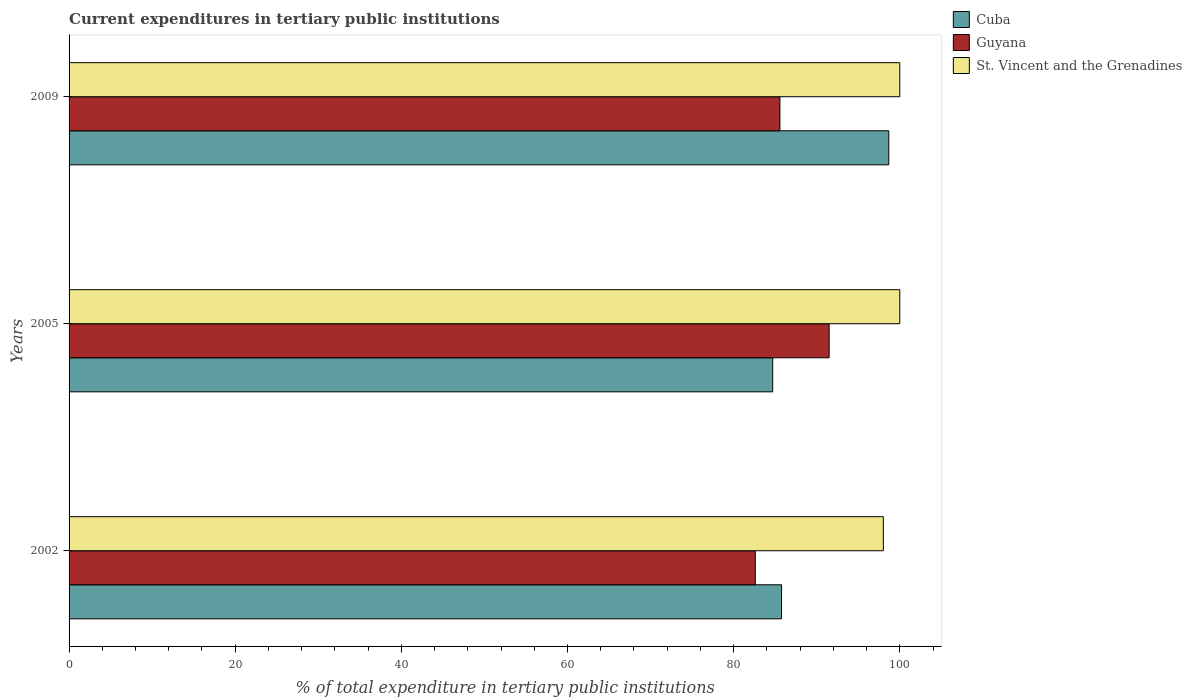Are the number of bars on each tick of the Y-axis equal?
Keep it short and to the point. Yes. How many bars are there on the 1st tick from the top?
Your answer should be very brief. 3. What is the current expenditures in tertiary public institutions in Guyana in 2002?
Ensure brevity in your answer.  82.6. Across all years, what is the maximum current expenditures in tertiary public institutions in Cuba?
Offer a very short reply. 98.67. Across all years, what is the minimum current expenditures in tertiary public institutions in Guyana?
Keep it short and to the point. 82.6. In which year was the current expenditures in tertiary public institutions in St. Vincent and the Grenadines minimum?
Offer a very short reply. 2002. What is the total current expenditures in tertiary public institutions in Guyana in the graph?
Offer a terse response. 259.67. What is the difference between the current expenditures in tertiary public institutions in Guyana in 2002 and that in 2009?
Offer a very short reply. -2.97. What is the difference between the current expenditures in tertiary public institutions in Guyana in 2009 and the current expenditures in tertiary public institutions in St. Vincent and the Grenadines in 2002?
Your response must be concise. -12.45. What is the average current expenditures in tertiary public institutions in Guyana per year?
Your response must be concise. 86.56. In the year 2009, what is the difference between the current expenditures in tertiary public institutions in Guyana and current expenditures in tertiary public institutions in St. Vincent and the Grenadines?
Provide a short and direct response. -14.43. What is the ratio of the current expenditures in tertiary public institutions in Cuba in 2002 to that in 2005?
Provide a succinct answer. 1.01. What is the difference between the highest and the second highest current expenditures in tertiary public institutions in Guyana?
Your answer should be very brief. 5.92. What is the difference between the highest and the lowest current expenditures in tertiary public institutions in St. Vincent and the Grenadines?
Keep it short and to the point. 1.98. In how many years, is the current expenditures in tertiary public institutions in Guyana greater than the average current expenditures in tertiary public institutions in Guyana taken over all years?
Make the answer very short. 1. Is the sum of the current expenditures in tertiary public institutions in St. Vincent and the Grenadines in 2002 and 2009 greater than the maximum current expenditures in tertiary public institutions in Guyana across all years?
Provide a succinct answer. Yes. What does the 1st bar from the top in 2002 represents?
Offer a terse response. St. Vincent and the Grenadines. What does the 3rd bar from the bottom in 2002 represents?
Your response must be concise. St. Vincent and the Grenadines. How many bars are there?
Provide a short and direct response. 9. Are all the bars in the graph horizontal?
Your answer should be compact. Yes. How many years are there in the graph?
Your answer should be very brief. 3. What is the difference between two consecutive major ticks on the X-axis?
Provide a short and direct response. 20. Are the values on the major ticks of X-axis written in scientific E-notation?
Offer a terse response. No. Does the graph contain grids?
Make the answer very short. No. Where does the legend appear in the graph?
Provide a succinct answer. Top right. How are the legend labels stacked?
Your answer should be very brief. Vertical. What is the title of the graph?
Your response must be concise. Current expenditures in tertiary public institutions. Does "Turkmenistan" appear as one of the legend labels in the graph?
Make the answer very short. No. What is the label or title of the X-axis?
Give a very brief answer. % of total expenditure in tertiary public institutions. What is the % of total expenditure in tertiary public institutions of Cuba in 2002?
Give a very brief answer. 85.77. What is the % of total expenditure in tertiary public institutions of Guyana in 2002?
Provide a succinct answer. 82.6. What is the % of total expenditure in tertiary public institutions in St. Vincent and the Grenadines in 2002?
Provide a succinct answer. 98.02. What is the % of total expenditure in tertiary public institutions in Cuba in 2005?
Your answer should be compact. 84.7. What is the % of total expenditure in tertiary public institutions in Guyana in 2005?
Offer a very short reply. 91.49. What is the % of total expenditure in tertiary public institutions in St. Vincent and the Grenadines in 2005?
Provide a succinct answer. 100. What is the % of total expenditure in tertiary public institutions of Cuba in 2009?
Offer a very short reply. 98.67. What is the % of total expenditure in tertiary public institutions in Guyana in 2009?
Give a very brief answer. 85.57. What is the % of total expenditure in tertiary public institutions of St. Vincent and the Grenadines in 2009?
Offer a terse response. 100. Across all years, what is the maximum % of total expenditure in tertiary public institutions in Cuba?
Your response must be concise. 98.67. Across all years, what is the maximum % of total expenditure in tertiary public institutions in Guyana?
Offer a very short reply. 91.49. Across all years, what is the minimum % of total expenditure in tertiary public institutions of Cuba?
Your answer should be very brief. 84.7. Across all years, what is the minimum % of total expenditure in tertiary public institutions of Guyana?
Your answer should be very brief. 82.6. Across all years, what is the minimum % of total expenditure in tertiary public institutions of St. Vincent and the Grenadines?
Provide a short and direct response. 98.02. What is the total % of total expenditure in tertiary public institutions of Cuba in the graph?
Make the answer very short. 269.14. What is the total % of total expenditure in tertiary public institutions in Guyana in the graph?
Your answer should be very brief. 259.67. What is the total % of total expenditure in tertiary public institutions of St. Vincent and the Grenadines in the graph?
Your answer should be compact. 298.02. What is the difference between the % of total expenditure in tertiary public institutions of Cuba in 2002 and that in 2005?
Your answer should be very brief. 1.07. What is the difference between the % of total expenditure in tertiary public institutions in Guyana in 2002 and that in 2005?
Keep it short and to the point. -8.89. What is the difference between the % of total expenditure in tertiary public institutions in St. Vincent and the Grenadines in 2002 and that in 2005?
Offer a very short reply. -1.98. What is the difference between the % of total expenditure in tertiary public institutions of Cuba in 2002 and that in 2009?
Provide a short and direct response. -12.9. What is the difference between the % of total expenditure in tertiary public institutions in Guyana in 2002 and that in 2009?
Offer a very short reply. -2.97. What is the difference between the % of total expenditure in tertiary public institutions in St. Vincent and the Grenadines in 2002 and that in 2009?
Make the answer very short. -1.98. What is the difference between the % of total expenditure in tertiary public institutions in Cuba in 2005 and that in 2009?
Your response must be concise. -13.97. What is the difference between the % of total expenditure in tertiary public institutions of Guyana in 2005 and that in 2009?
Provide a succinct answer. 5.92. What is the difference between the % of total expenditure in tertiary public institutions in St. Vincent and the Grenadines in 2005 and that in 2009?
Make the answer very short. 0. What is the difference between the % of total expenditure in tertiary public institutions of Cuba in 2002 and the % of total expenditure in tertiary public institutions of Guyana in 2005?
Provide a short and direct response. -5.73. What is the difference between the % of total expenditure in tertiary public institutions of Cuba in 2002 and the % of total expenditure in tertiary public institutions of St. Vincent and the Grenadines in 2005?
Provide a short and direct response. -14.23. What is the difference between the % of total expenditure in tertiary public institutions of Guyana in 2002 and the % of total expenditure in tertiary public institutions of St. Vincent and the Grenadines in 2005?
Keep it short and to the point. -17.4. What is the difference between the % of total expenditure in tertiary public institutions of Cuba in 2002 and the % of total expenditure in tertiary public institutions of Guyana in 2009?
Give a very brief answer. 0.2. What is the difference between the % of total expenditure in tertiary public institutions in Cuba in 2002 and the % of total expenditure in tertiary public institutions in St. Vincent and the Grenadines in 2009?
Make the answer very short. -14.23. What is the difference between the % of total expenditure in tertiary public institutions in Guyana in 2002 and the % of total expenditure in tertiary public institutions in St. Vincent and the Grenadines in 2009?
Offer a very short reply. -17.4. What is the difference between the % of total expenditure in tertiary public institutions in Cuba in 2005 and the % of total expenditure in tertiary public institutions in Guyana in 2009?
Your response must be concise. -0.87. What is the difference between the % of total expenditure in tertiary public institutions of Cuba in 2005 and the % of total expenditure in tertiary public institutions of St. Vincent and the Grenadines in 2009?
Keep it short and to the point. -15.3. What is the difference between the % of total expenditure in tertiary public institutions in Guyana in 2005 and the % of total expenditure in tertiary public institutions in St. Vincent and the Grenadines in 2009?
Provide a succinct answer. -8.51. What is the average % of total expenditure in tertiary public institutions in Cuba per year?
Provide a succinct answer. 89.71. What is the average % of total expenditure in tertiary public institutions in Guyana per year?
Offer a very short reply. 86.56. What is the average % of total expenditure in tertiary public institutions in St. Vincent and the Grenadines per year?
Offer a very short reply. 99.34. In the year 2002, what is the difference between the % of total expenditure in tertiary public institutions of Cuba and % of total expenditure in tertiary public institutions of Guyana?
Keep it short and to the point. 3.17. In the year 2002, what is the difference between the % of total expenditure in tertiary public institutions in Cuba and % of total expenditure in tertiary public institutions in St. Vincent and the Grenadines?
Offer a very short reply. -12.25. In the year 2002, what is the difference between the % of total expenditure in tertiary public institutions of Guyana and % of total expenditure in tertiary public institutions of St. Vincent and the Grenadines?
Your answer should be compact. -15.42. In the year 2005, what is the difference between the % of total expenditure in tertiary public institutions in Cuba and % of total expenditure in tertiary public institutions in Guyana?
Offer a very short reply. -6.79. In the year 2005, what is the difference between the % of total expenditure in tertiary public institutions in Cuba and % of total expenditure in tertiary public institutions in St. Vincent and the Grenadines?
Make the answer very short. -15.3. In the year 2005, what is the difference between the % of total expenditure in tertiary public institutions of Guyana and % of total expenditure in tertiary public institutions of St. Vincent and the Grenadines?
Keep it short and to the point. -8.51. In the year 2009, what is the difference between the % of total expenditure in tertiary public institutions in Cuba and % of total expenditure in tertiary public institutions in Guyana?
Keep it short and to the point. 13.1. In the year 2009, what is the difference between the % of total expenditure in tertiary public institutions in Cuba and % of total expenditure in tertiary public institutions in St. Vincent and the Grenadines?
Your response must be concise. -1.33. In the year 2009, what is the difference between the % of total expenditure in tertiary public institutions of Guyana and % of total expenditure in tertiary public institutions of St. Vincent and the Grenadines?
Give a very brief answer. -14.43. What is the ratio of the % of total expenditure in tertiary public institutions of Cuba in 2002 to that in 2005?
Offer a terse response. 1.01. What is the ratio of the % of total expenditure in tertiary public institutions in Guyana in 2002 to that in 2005?
Your response must be concise. 0.9. What is the ratio of the % of total expenditure in tertiary public institutions of St. Vincent and the Grenadines in 2002 to that in 2005?
Your response must be concise. 0.98. What is the ratio of the % of total expenditure in tertiary public institutions of Cuba in 2002 to that in 2009?
Provide a short and direct response. 0.87. What is the ratio of the % of total expenditure in tertiary public institutions of Guyana in 2002 to that in 2009?
Make the answer very short. 0.97. What is the ratio of the % of total expenditure in tertiary public institutions of St. Vincent and the Grenadines in 2002 to that in 2009?
Give a very brief answer. 0.98. What is the ratio of the % of total expenditure in tertiary public institutions in Cuba in 2005 to that in 2009?
Your answer should be very brief. 0.86. What is the ratio of the % of total expenditure in tertiary public institutions in Guyana in 2005 to that in 2009?
Keep it short and to the point. 1.07. What is the ratio of the % of total expenditure in tertiary public institutions in St. Vincent and the Grenadines in 2005 to that in 2009?
Ensure brevity in your answer.  1. What is the difference between the highest and the second highest % of total expenditure in tertiary public institutions of Cuba?
Your answer should be very brief. 12.9. What is the difference between the highest and the second highest % of total expenditure in tertiary public institutions of Guyana?
Offer a terse response. 5.92. What is the difference between the highest and the lowest % of total expenditure in tertiary public institutions in Cuba?
Your answer should be very brief. 13.97. What is the difference between the highest and the lowest % of total expenditure in tertiary public institutions in Guyana?
Your response must be concise. 8.89. What is the difference between the highest and the lowest % of total expenditure in tertiary public institutions in St. Vincent and the Grenadines?
Make the answer very short. 1.98. 